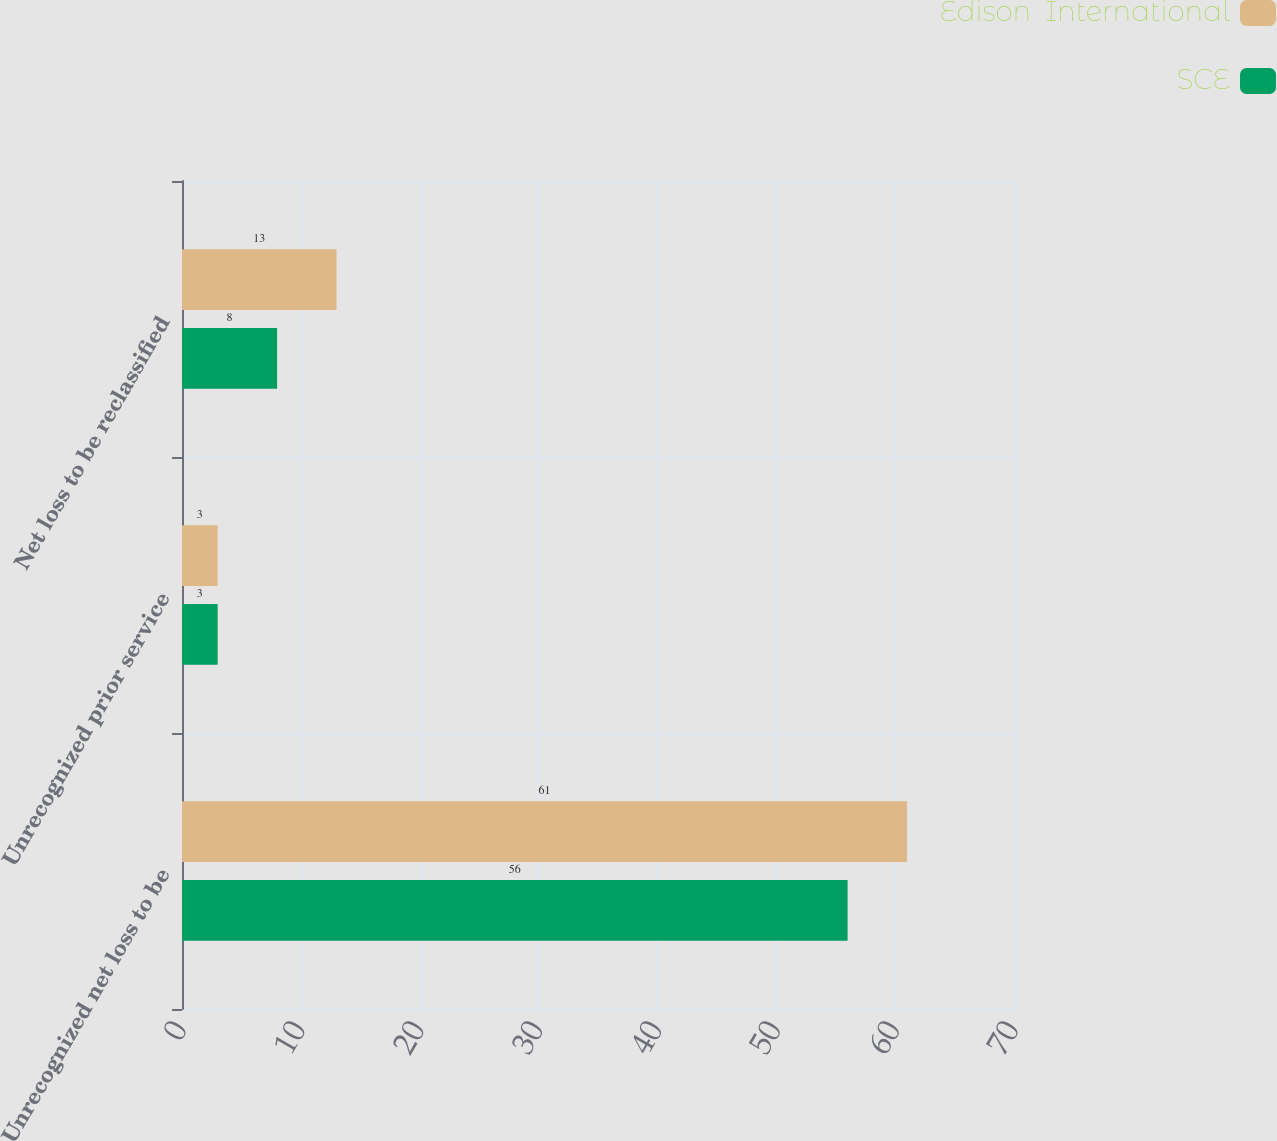<chart> <loc_0><loc_0><loc_500><loc_500><stacked_bar_chart><ecel><fcel>Unrecognized net loss to be<fcel>Unrecognized prior service<fcel>Net loss to be reclassified<nl><fcel>Edison  International<fcel>61<fcel>3<fcel>13<nl><fcel>SCE<fcel>56<fcel>3<fcel>8<nl></chart> 